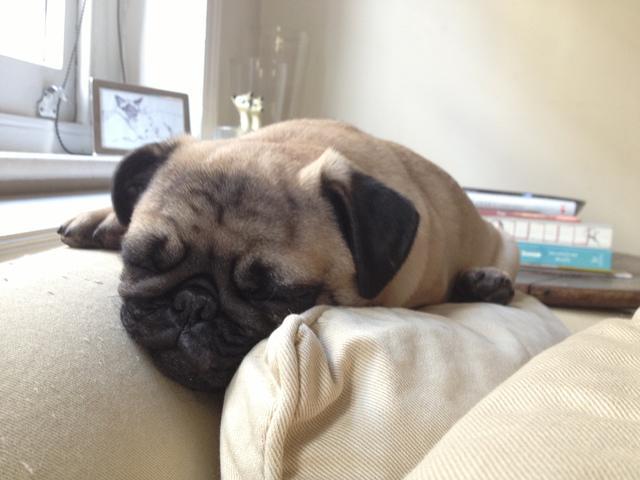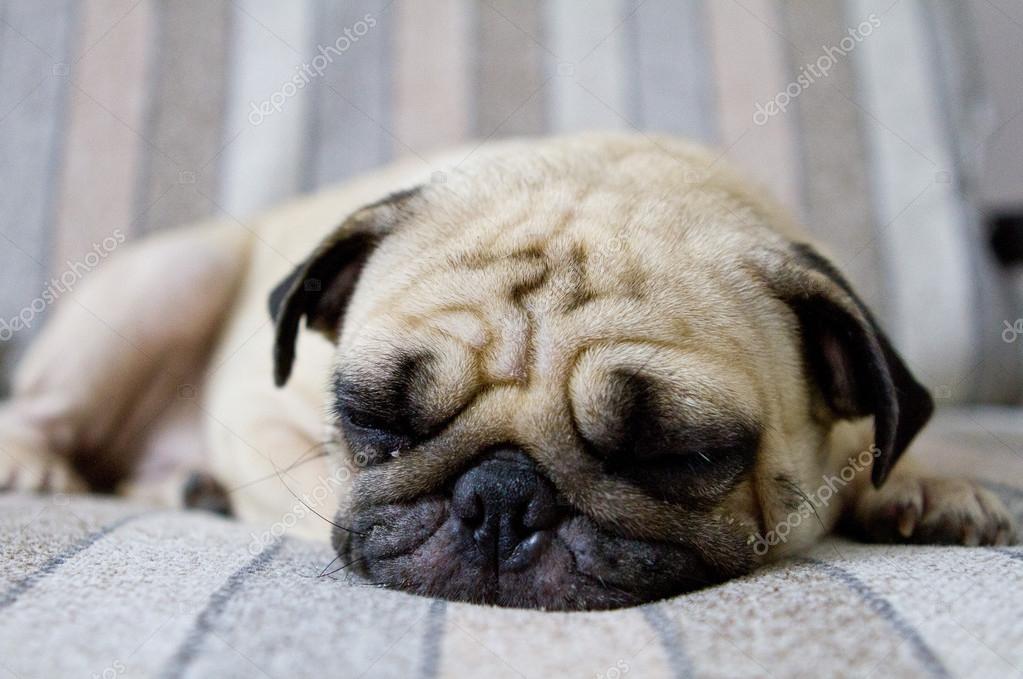The first image is the image on the left, the second image is the image on the right. Examine the images to the left and right. Is the description "There is exactly 1 puppy lying down in the image on the left." accurate? Answer yes or no. Yes. The first image is the image on the left, the second image is the image on the right. Given the left and right images, does the statement "One image shows a pug puppy with its head resting on the fur of a real animal, and the other image shows one real pug with its head resting on something plush." hold true? Answer yes or no. No. 